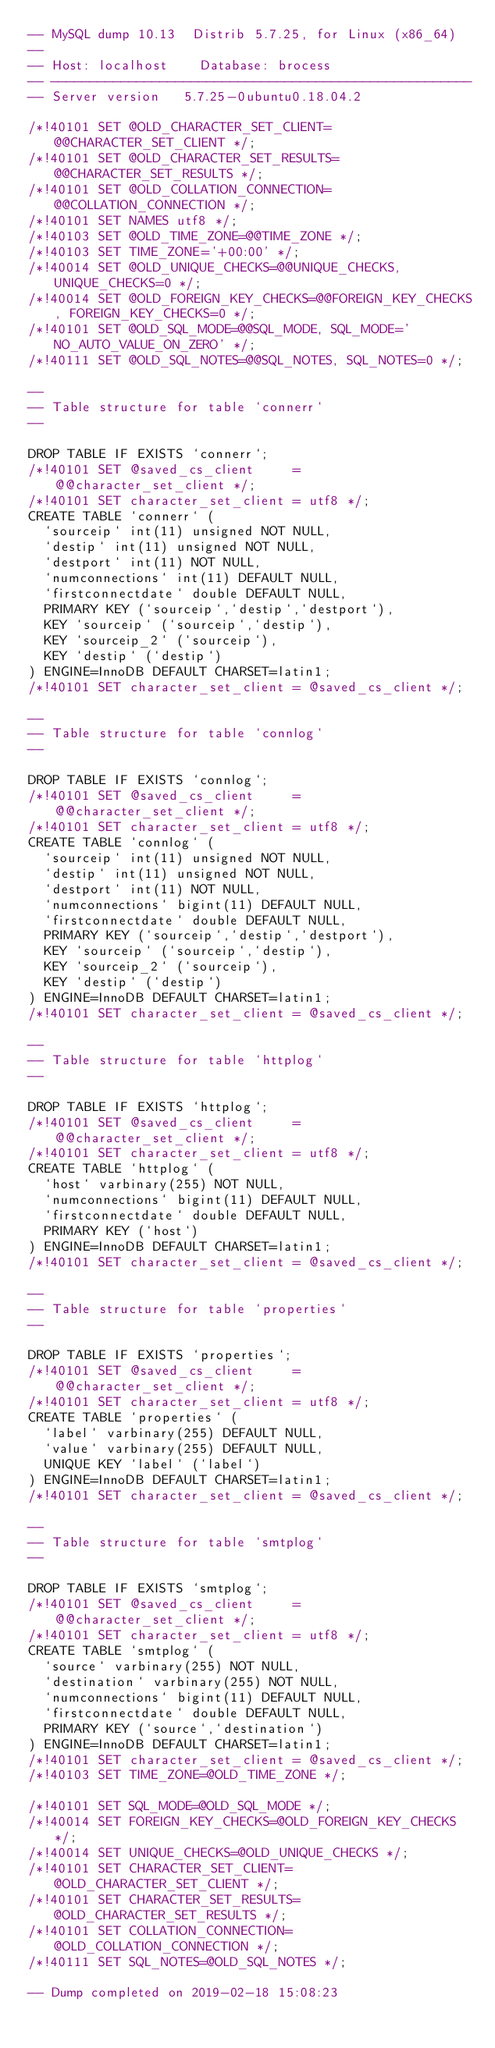Convert code to text. <code><loc_0><loc_0><loc_500><loc_500><_SQL_>-- MySQL dump 10.13  Distrib 5.7.25, for Linux (x86_64)
--
-- Host: localhost    Database: brocess
-- ------------------------------------------------------
-- Server version	5.7.25-0ubuntu0.18.04.2

/*!40101 SET @OLD_CHARACTER_SET_CLIENT=@@CHARACTER_SET_CLIENT */;
/*!40101 SET @OLD_CHARACTER_SET_RESULTS=@@CHARACTER_SET_RESULTS */;
/*!40101 SET @OLD_COLLATION_CONNECTION=@@COLLATION_CONNECTION */;
/*!40101 SET NAMES utf8 */;
/*!40103 SET @OLD_TIME_ZONE=@@TIME_ZONE */;
/*!40103 SET TIME_ZONE='+00:00' */;
/*!40014 SET @OLD_UNIQUE_CHECKS=@@UNIQUE_CHECKS, UNIQUE_CHECKS=0 */;
/*!40014 SET @OLD_FOREIGN_KEY_CHECKS=@@FOREIGN_KEY_CHECKS, FOREIGN_KEY_CHECKS=0 */;
/*!40101 SET @OLD_SQL_MODE=@@SQL_MODE, SQL_MODE='NO_AUTO_VALUE_ON_ZERO' */;
/*!40111 SET @OLD_SQL_NOTES=@@SQL_NOTES, SQL_NOTES=0 */;

--
-- Table structure for table `connerr`
--

DROP TABLE IF EXISTS `connerr`;
/*!40101 SET @saved_cs_client     = @@character_set_client */;
/*!40101 SET character_set_client = utf8 */;
CREATE TABLE `connerr` (
  `sourceip` int(11) unsigned NOT NULL,
  `destip` int(11) unsigned NOT NULL,
  `destport` int(11) NOT NULL,
  `numconnections` int(11) DEFAULT NULL,
  `firstconnectdate` double DEFAULT NULL,
  PRIMARY KEY (`sourceip`,`destip`,`destport`),
  KEY `sourceip` (`sourceip`,`destip`),
  KEY `sourceip_2` (`sourceip`),
  KEY `destip` (`destip`)
) ENGINE=InnoDB DEFAULT CHARSET=latin1;
/*!40101 SET character_set_client = @saved_cs_client */;

--
-- Table structure for table `connlog`
--

DROP TABLE IF EXISTS `connlog`;
/*!40101 SET @saved_cs_client     = @@character_set_client */;
/*!40101 SET character_set_client = utf8 */;
CREATE TABLE `connlog` (
  `sourceip` int(11) unsigned NOT NULL,
  `destip` int(11) unsigned NOT NULL,
  `destport` int(11) NOT NULL,
  `numconnections` bigint(11) DEFAULT NULL,
  `firstconnectdate` double DEFAULT NULL,
  PRIMARY KEY (`sourceip`,`destip`,`destport`),
  KEY `sourceip` (`sourceip`,`destip`),
  KEY `sourceip_2` (`sourceip`),
  KEY `destip` (`destip`)
) ENGINE=InnoDB DEFAULT CHARSET=latin1;
/*!40101 SET character_set_client = @saved_cs_client */;

--
-- Table structure for table `httplog`
--

DROP TABLE IF EXISTS `httplog`;
/*!40101 SET @saved_cs_client     = @@character_set_client */;
/*!40101 SET character_set_client = utf8 */;
CREATE TABLE `httplog` (
  `host` varbinary(255) NOT NULL,
  `numconnections` bigint(11) DEFAULT NULL,
  `firstconnectdate` double DEFAULT NULL,
  PRIMARY KEY (`host`)
) ENGINE=InnoDB DEFAULT CHARSET=latin1;
/*!40101 SET character_set_client = @saved_cs_client */;

--
-- Table structure for table `properties`
--

DROP TABLE IF EXISTS `properties`;
/*!40101 SET @saved_cs_client     = @@character_set_client */;
/*!40101 SET character_set_client = utf8 */;
CREATE TABLE `properties` (
  `label` varbinary(255) DEFAULT NULL,
  `value` varbinary(255) DEFAULT NULL,
  UNIQUE KEY `label` (`label`)
) ENGINE=InnoDB DEFAULT CHARSET=latin1;
/*!40101 SET character_set_client = @saved_cs_client */;

--
-- Table structure for table `smtplog`
--

DROP TABLE IF EXISTS `smtplog`;
/*!40101 SET @saved_cs_client     = @@character_set_client */;
/*!40101 SET character_set_client = utf8 */;
CREATE TABLE `smtplog` (
  `source` varbinary(255) NOT NULL,
  `destination` varbinary(255) NOT NULL,
  `numconnections` bigint(11) DEFAULT NULL,
  `firstconnectdate` double DEFAULT NULL,
  PRIMARY KEY (`source`,`destination`)
) ENGINE=InnoDB DEFAULT CHARSET=latin1;
/*!40101 SET character_set_client = @saved_cs_client */;
/*!40103 SET TIME_ZONE=@OLD_TIME_ZONE */;

/*!40101 SET SQL_MODE=@OLD_SQL_MODE */;
/*!40014 SET FOREIGN_KEY_CHECKS=@OLD_FOREIGN_KEY_CHECKS */;
/*!40014 SET UNIQUE_CHECKS=@OLD_UNIQUE_CHECKS */;
/*!40101 SET CHARACTER_SET_CLIENT=@OLD_CHARACTER_SET_CLIENT */;
/*!40101 SET CHARACTER_SET_RESULTS=@OLD_CHARACTER_SET_RESULTS */;
/*!40101 SET COLLATION_CONNECTION=@OLD_COLLATION_CONNECTION */;
/*!40111 SET SQL_NOTES=@OLD_SQL_NOTES */;

-- Dump completed on 2019-02-18 15:08:23
</code> 